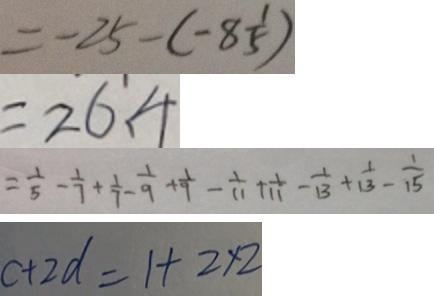<formula> <loc_0><loc_0><loc_500><loc_500>= - 2 5 - ( - 8 \frac { 1 } { 5 } ) 
 = 2 6 . 4 
 = \frac { 1 } { 5 } - \frac { 1 } { 7 } + \frac { 1 } { 7 } - \frac { 1 } { 9 } + \frac { 1 } { 9 } - \frac { 1 } { 1 1 } + \frac { 1 } { 1 1 } - \frac { 1 } { 1 3 } + \frac { 1 } { 1 3 } - \frac { 1 } { 1 5 } 
 c + 2 d = 1 + 2 \times 2</formula> 